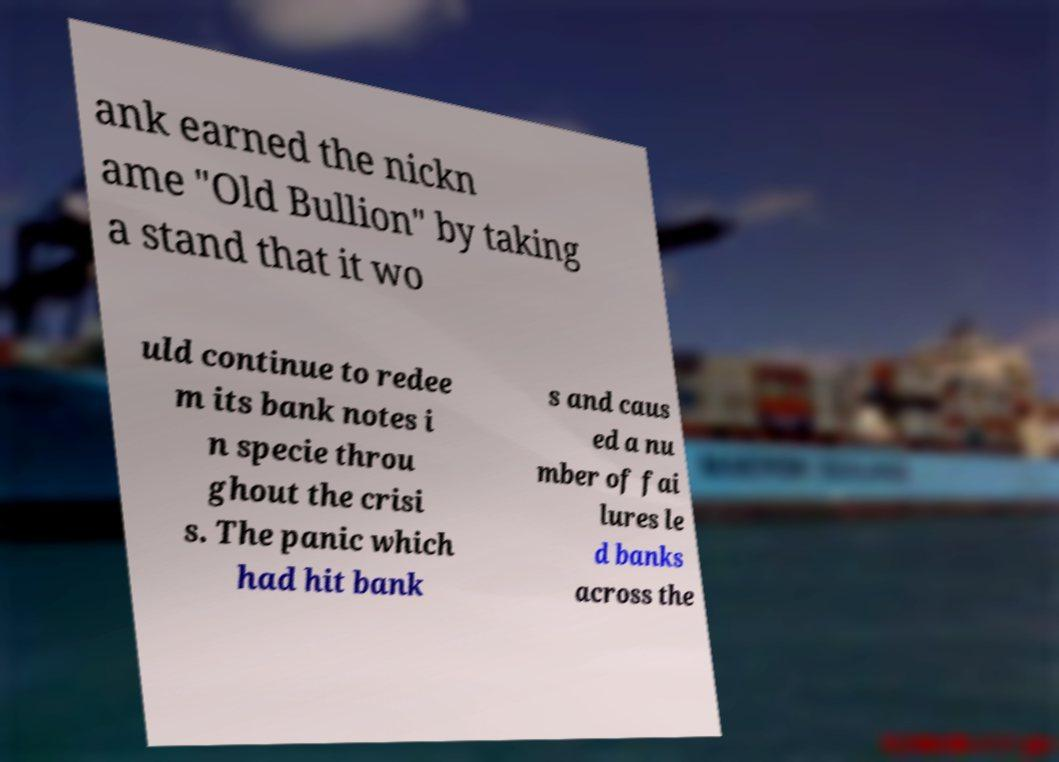Could you assist in decoding the text presented in this image and type it out clearly? ank earned the nickn ame "Old Bullion" by taking a stand that it wo uld continue to redee m its bank notes i n specie throu ghout the crisi s. The panic which had hit bank s and caus ed a nu mber of fai lures le d banks across the 